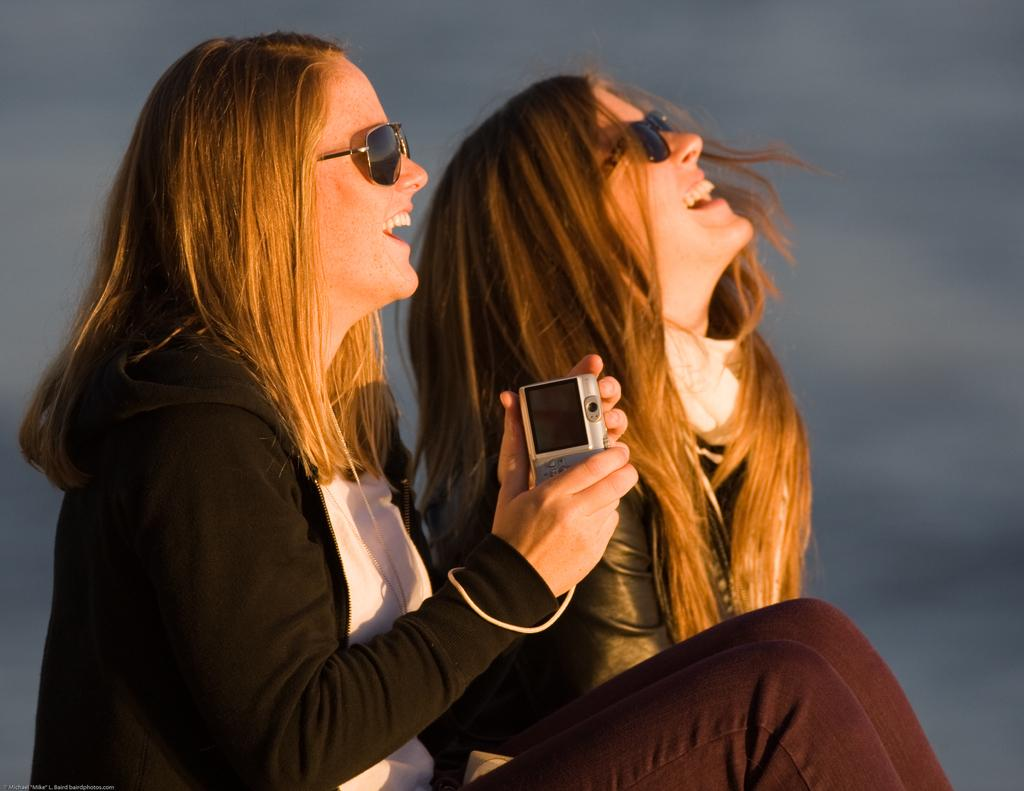How many people are in the image? There are two women in the image. What are the women doing in the image? The women are sitting and smiling. Can you describe what one of the women is holding? One of the women is holding an electronic device. What type of lunch is being prepared by the creator in the image? There is no creator or lunch preparation visible in the image; it features two women sitting and smiling. 